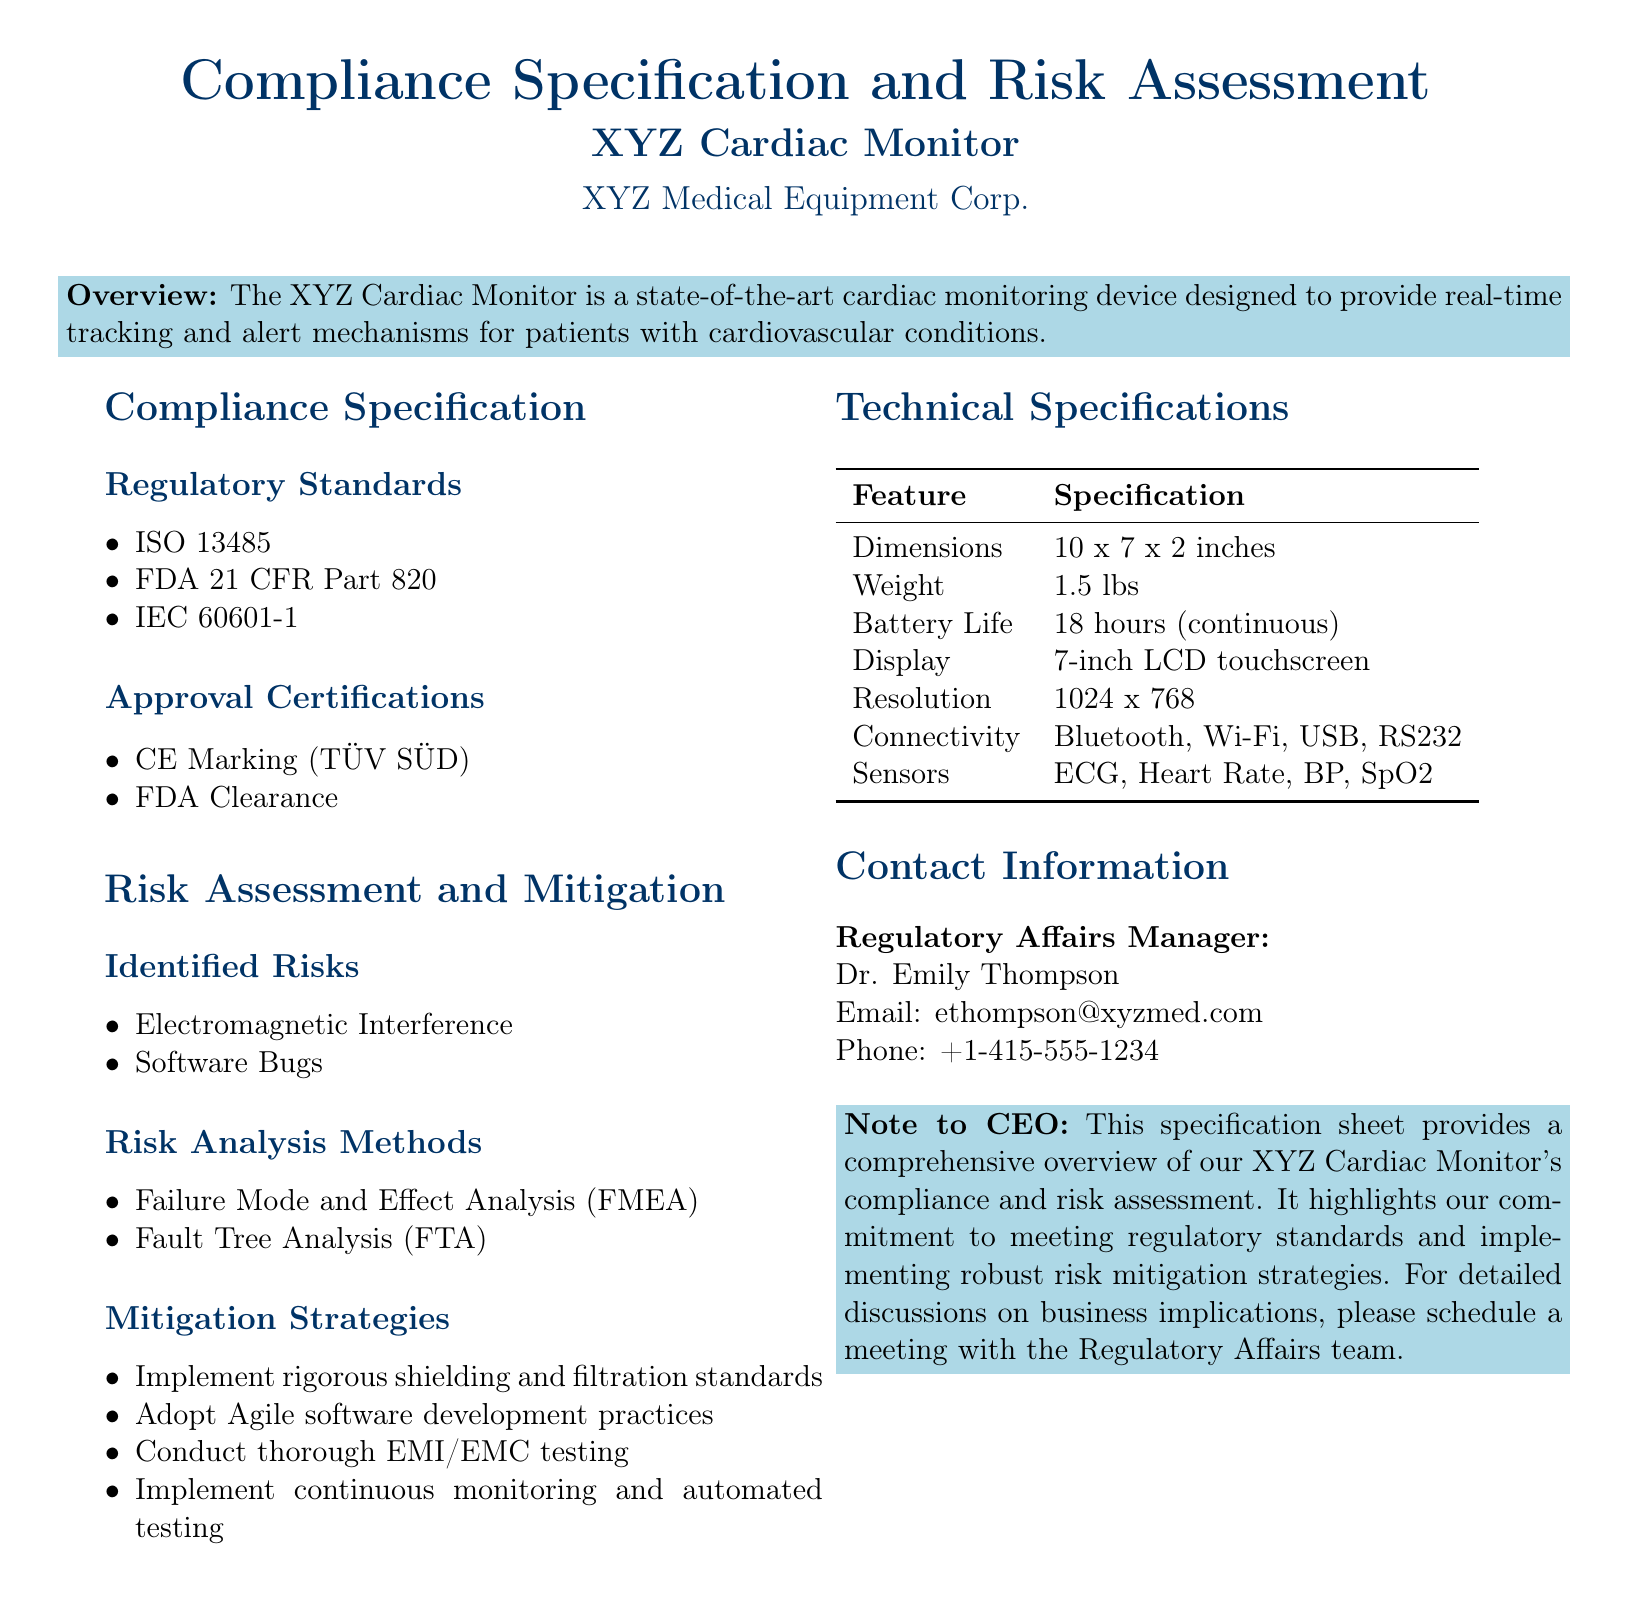What regulatory standards does the product comply with? The regulatory standards are listed in the Compliance Specification section of the document.
Answer: ISO 13485, FDA 21 CFR Part 820, IEC 60601-1 Who is the Regulatory Affairs Manager? The Regulatory Affairs Manager's name is mentioned in the Contact Information section.
Answer: Dr. Emily Thompson What is the battery life of the XYZ Cardiac Monitor? The battery life is specified in the Technical Specifications section of the document.
Answer: 18 hours (continuous) What risk analysis methods are used for the device? The risk analysis methods are listed under Risk Assessment and Mitigation in the document.
Answer: Failure Mode and Effect Analysis (FMEA), Fault Tree Analysis (FTA) What mitigation strategy is employed for software bugs? The mitigation strategies are specified in the Risk Assessment and Mitigation section.
Answer: Adopt Agile software development practices How much does the XYZ Cardiac Monitor weigh? The weight is provided in the Technical Specifications section.
Answer: 1.5 lbs What type of certification is the device approved for in the EU? The approval certifications are mentioned in the Compliance Specification section of the document.
Answer: CE Marking (TÜV SÜD) What sensors are included in the XYZ Cardiac Monitor? The sensors are listed under Technical Specifications in the document.
Answer: ECG, Heart Rate, BP, SpO2 What is the display type of the XYZ Cardiac Monitor? The display type is mentioned in the Technical Specifications section.
Answer: 7-inch LCD touchscreen 